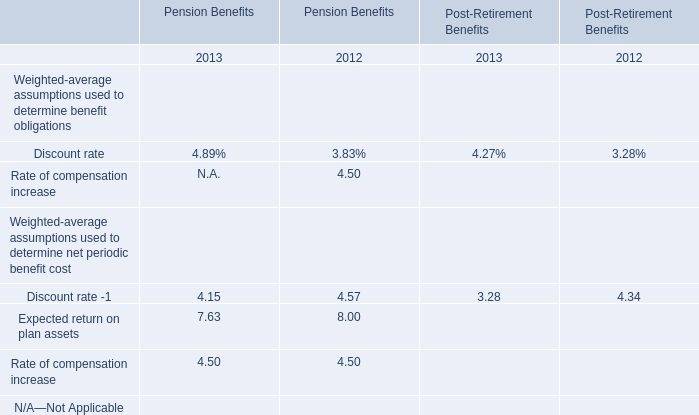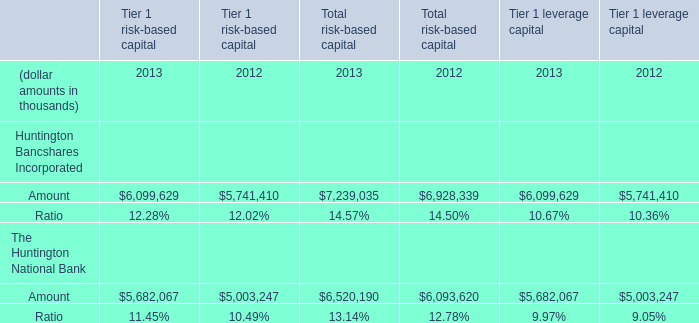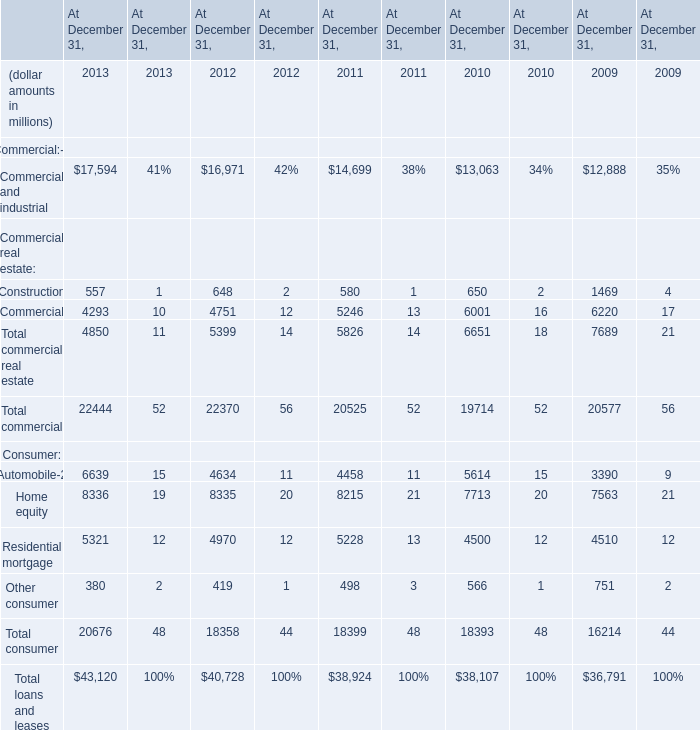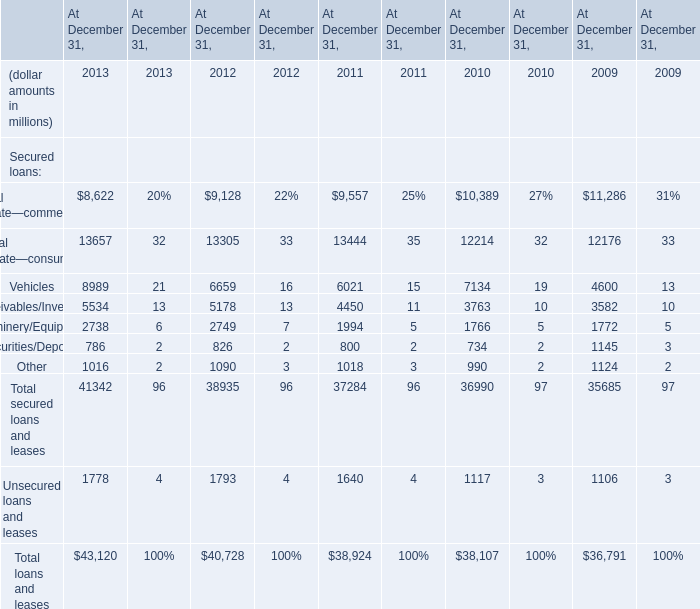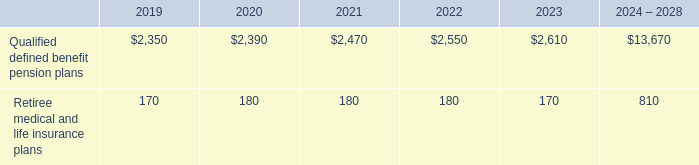From 2010 and 2012,how long does the amount of Total secured loans and leases on December 31 keep growing? 
Answer: 3. 